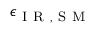<formula> <loc_0><loc_0><loc_500><loc_500>\epsilon _ { I R , S M }</formula> 